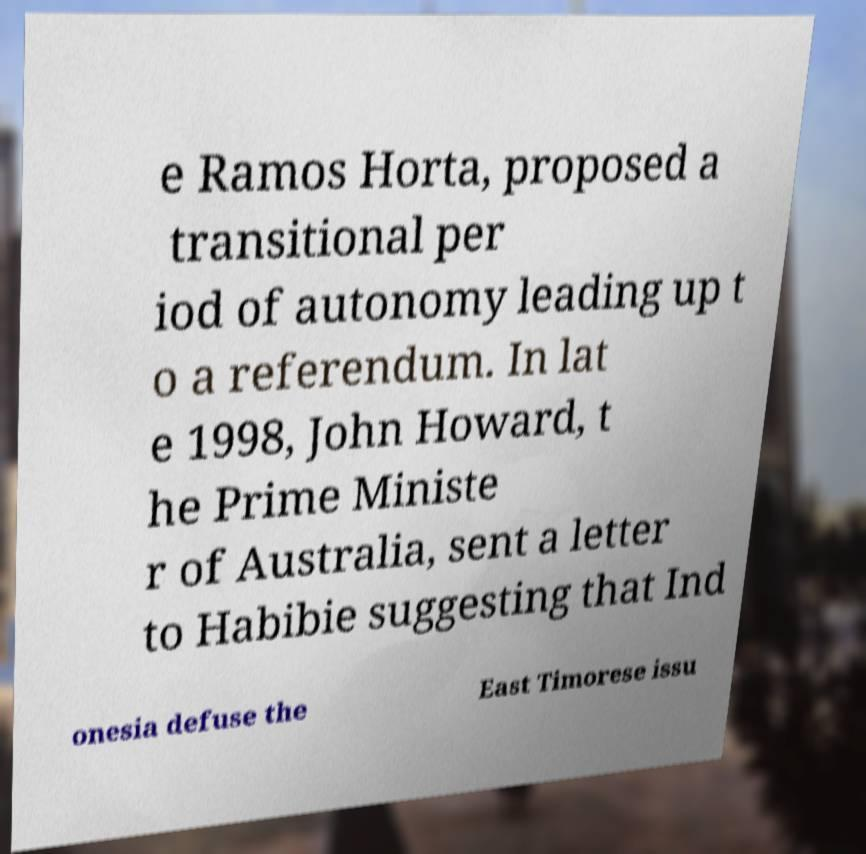There's text embedded in this image that I need extracted. Can you transcribe it verbatim? e Ramos Horta, proposed a transitional per iod of autonomy leading up t o a referendum. In lat e 1998, John Howard, t he Prime Ministe r of Australia, sent a letter to Habibie suggesting that Ind onesia defuse the East Timorese issu 